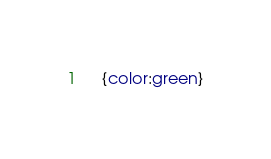<code> <loc_0><loc_0><loc_500><loc_500><_CSS_>	{color:green}</code> 